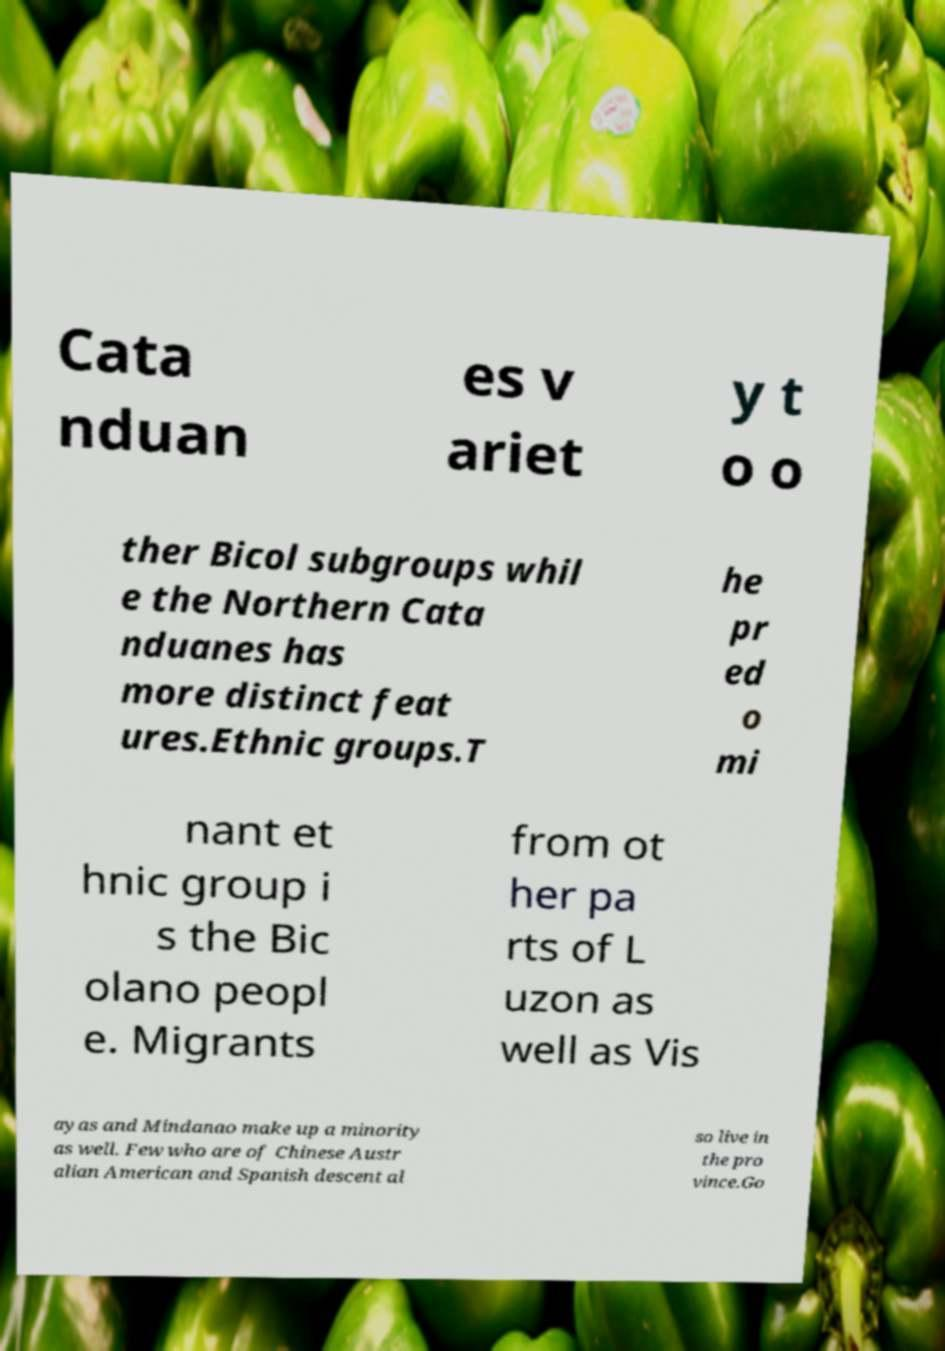Please identify and transcribe the text found in this image. Cata nduan es v ariet y t o o ther Bicol subgroups whil e the Northern Cata nduanes has more distinct feat ures.Ethnic groups.T he pr ed o mi nant et hnic group i s the Bic olano peopl e. Migrants from ot her pa rts of L uzon as well as Vis ayas and Mindanao make up a minority as well. Few who are of Chinese Austr alian American and Spanish descent al so live in the pro vince.Go 